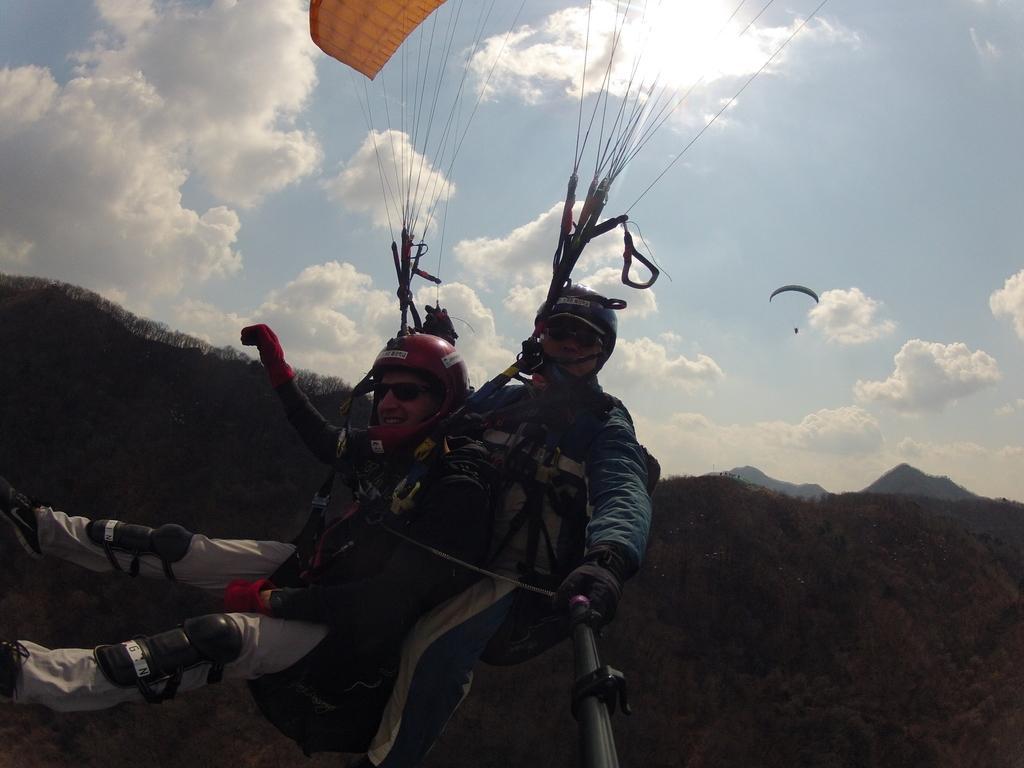How would you summarize this image in a sentence or two? In this image, we can the skydiving off a few people. Among them, we can see a person holding an object. We can see the hills and the sky with clouds. 